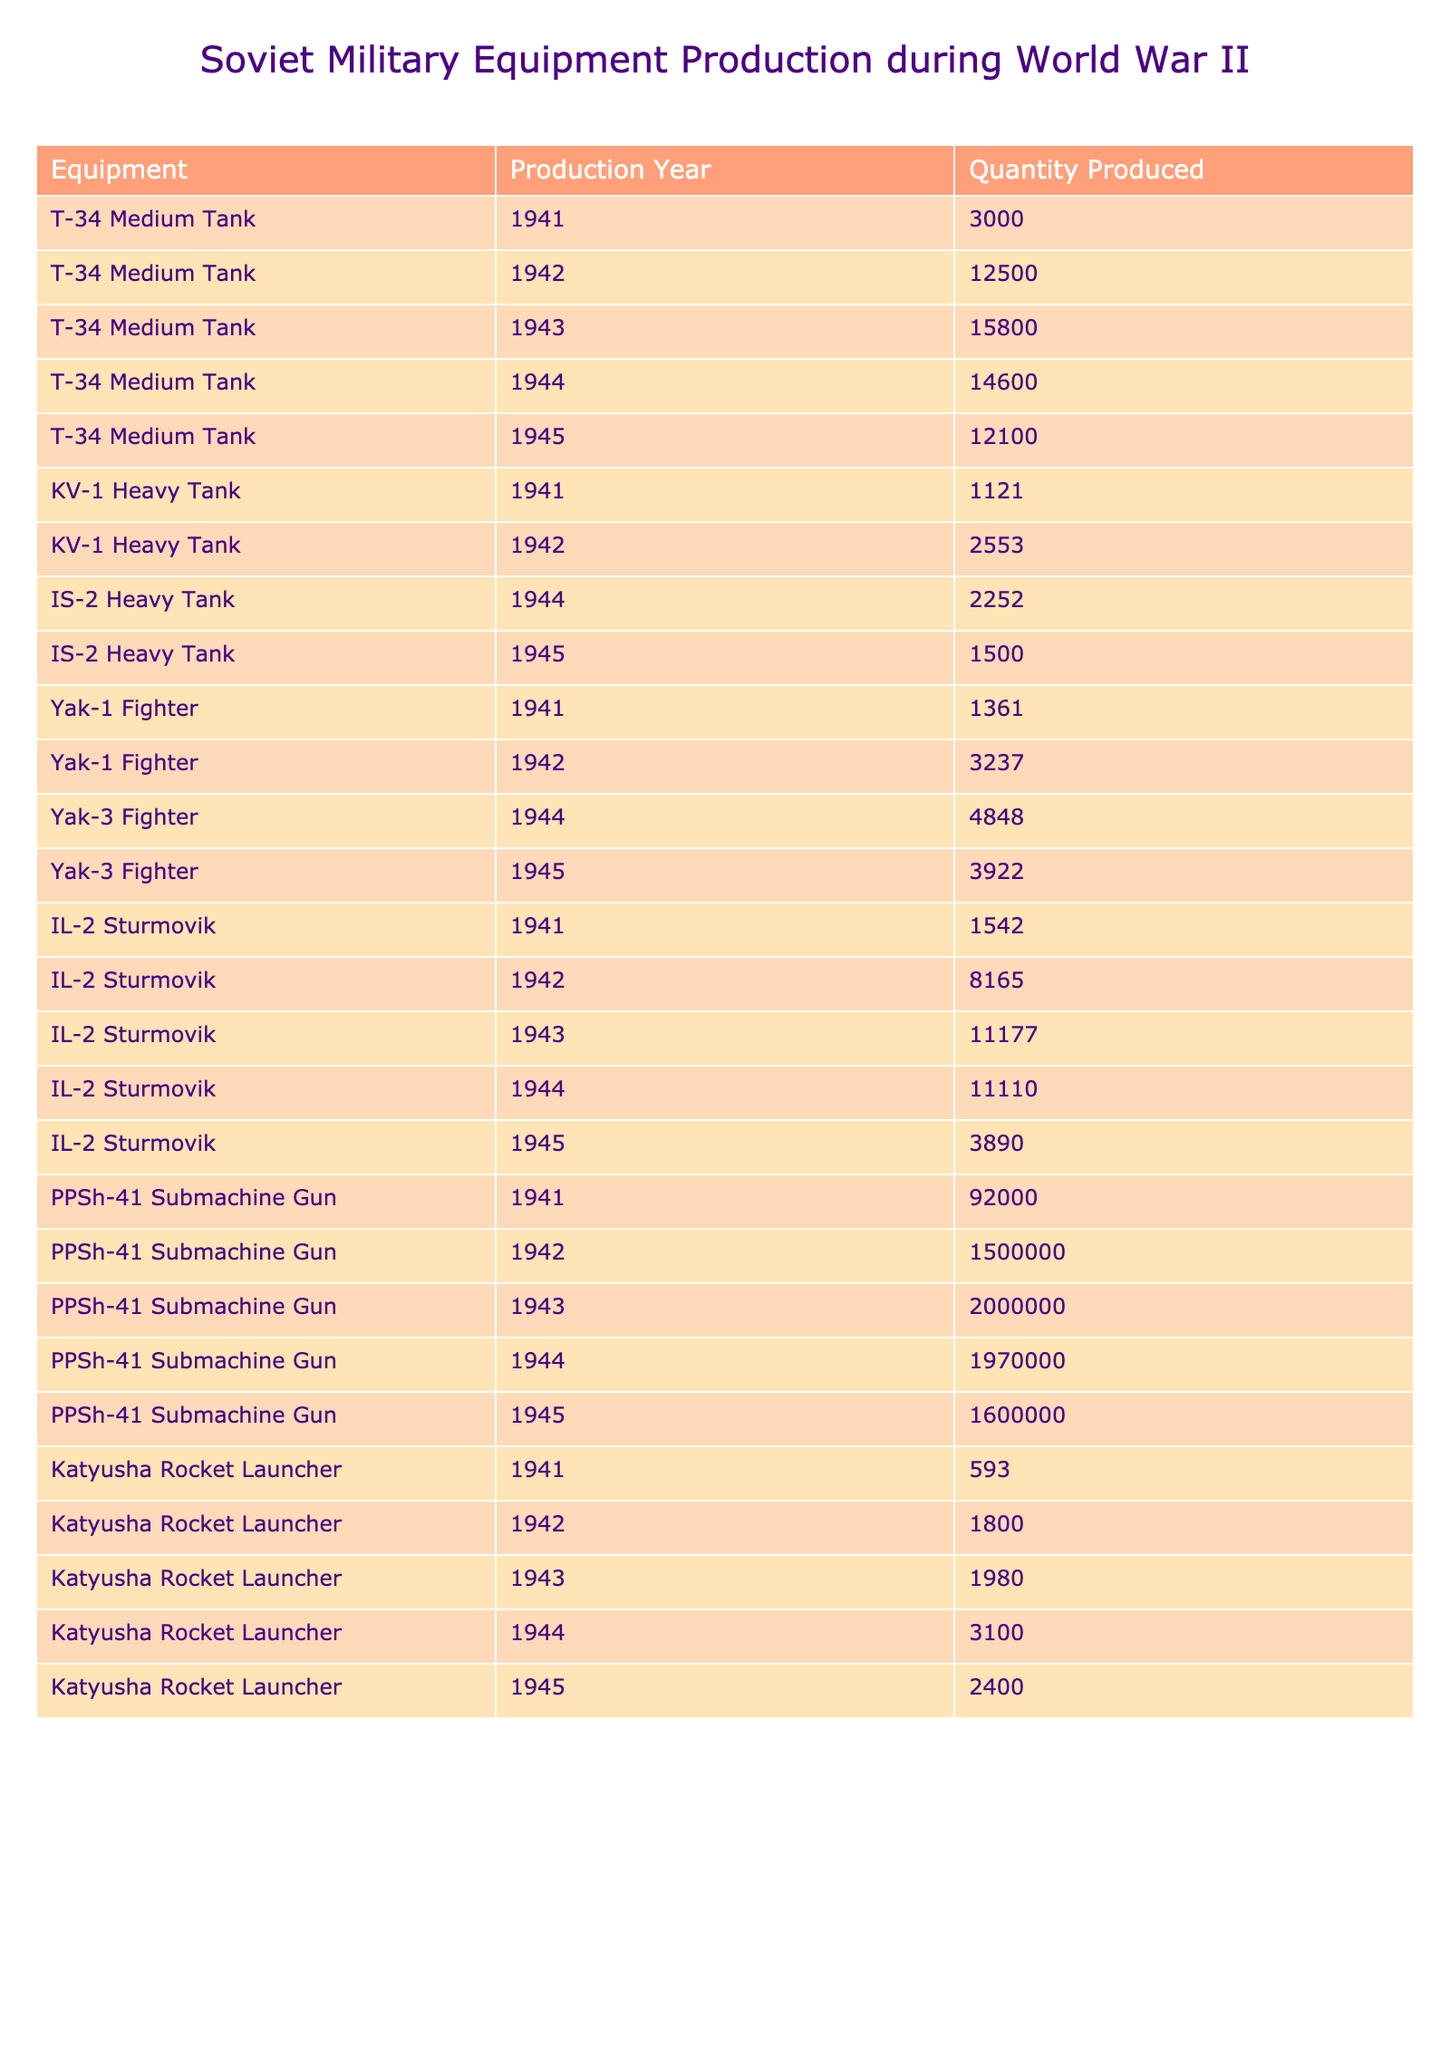What was the total production of T-34 Medium Tanks during the war? To find the total production, we need to sum the quantities produced for each year from the table: 3000 (1941) + 12500 (1942) + 15800 (1943) + 14600 (1944) + 12100 (1945) = 57000.
Answer: 57000 In which year was the highest quantity of Yak-1 Fighters produced? By looking at the production numbers in the table for Yak-1 Fighters, we see that 3237 were produced in 1942, and this is the maximum compared to 1361 (1941).
Answer: 1942 Did the production of the PPSh-41 Submachine Gun increase every year? If we check the quantities for each year, we see that it increased from 92000 (1941) to 1500000 (1942), then to 2000000 (1943), and then slightly decreased to 1970000 (1944) before decreasing again to 1600000 (1945). So the production did not increase every year.
Answer: No What was the average production of IL-2 Sturmovik across all years? To find the average, add the totals produced: 1542 (1941) + 8165 (1942) + 11177 (1943) + 11110 (1944) + 3890 (1945) = 40674. There are 5 years, so we divide 40674 by 5 to get an average of 8134.8.
Answer: 8134.8 Which piece of equipment had the highest total production in a single year? Comparing the maximum quantities across all pieces of equipment, we can see that the PPSh-41 Submachine Gun had the highest quantity produced in 1944 with 1970000, which is larger than any other pieces of equipment in any year.
Answer: PPSh-41 Submachine Gun in 1944 How many more T-34 Medium Tanks were produced in 1943 than in 1945? The production in 1943 is 15800, while in 1945 it is 12100. The difference = 15800 - 12100 = 3700.
Answer: 3700 Is the total production of IS-2 Heavy Tanks greater than the total production of Yak-3 Fighters? For IS-2 Heavy Tanks, we add: 2252 (1944) + 1500 (1945) = 3752. For Yak-3 Fighters: 4848 (1944) + 3922 (1945) = 8760. Since 3752 is less than 8760, the statement is false.
Answer: No What was the combined production of Katyusha Rocket Launchers in the last two years of the war? Add the production for 1944 and 1945: 3100 (1944) + 2400 (1945) = 5500.
Answer: 5500 In which year did the Soviet Union produce the least number of KV-1 Heavy Tanks? Looking at the production numbers for KV-1 Heavy Tanks, the lowest production was in 1941 with 1121 units, compared to 2553 in 1942.
Answer: 1941 What percentage of the total production for the PPSh-41 from 1941 to 1945 was produced in 1944? The total production from 1941 to 1945 is 92000 + 1500000 + 2000000 + 1970000 + 1600000 = 6200000. The production in 1944 is 1970000. To find the percentage: (1970000 / 6200000) * 100 = approximately 31.77%.
Answer: 31.77% 